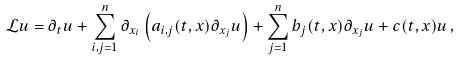Convert formula to latex. <formula><loc_0><loc_0><loc_500><loc_500>\mathcal { L } u = \partial _ { t } u + \sum _ { i , j = 1 } ^ { n } \partial _ { x _ { i } } \left ( a _ { i , j } ( t , x ) \partial _ { x _ { j } } u \right ) + \sum _ { j = 1 } ^ { n } b _ { j } ( t , x ) \partial _ { x _ { j } } u + c ( t , x ) u \, ,</formula> 